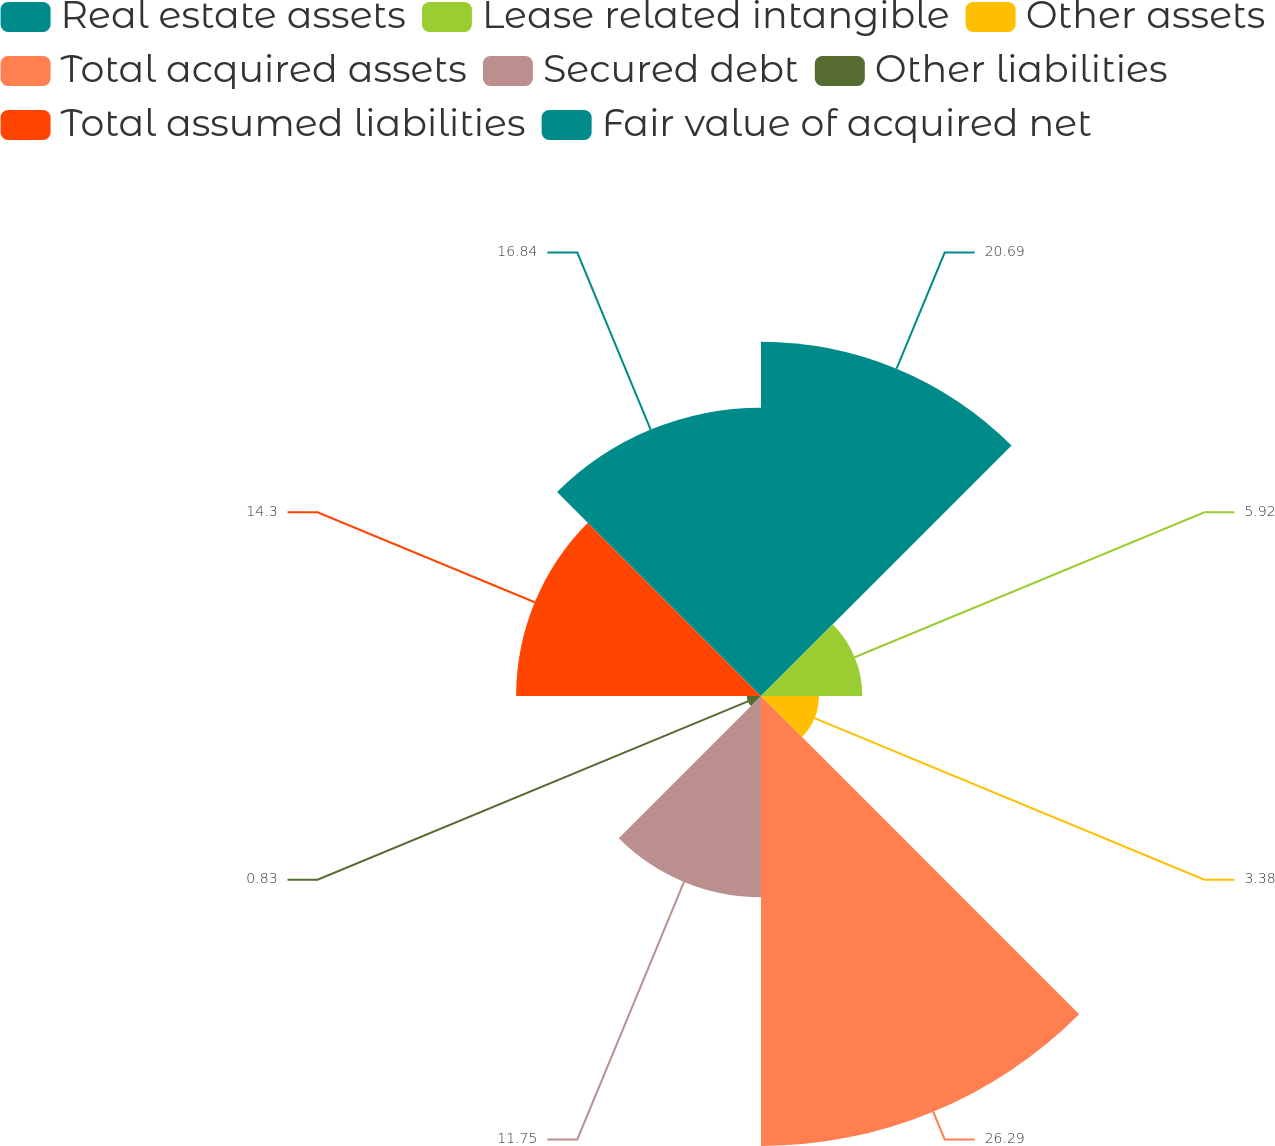Convert chart. <chart><loc_0><loc_0><loc_500><loc_500><pie_chart><fcel>Real estate assets<fcel>Lease related intangible<fcel>Other assets<fcel>Total acquired assets<fcel>Secured debt<fcel>Other liabilities<fcel>Total assumed liabilities<fcel>Fair value of acquired net<nl><fcel>20.69%<fcel>5.92%<fcel>3.38%<fcel>26.28%<fcel>11.75%<fcel>0.83%<fcel>14.3%<fcel>16.84%<nl></chart> 